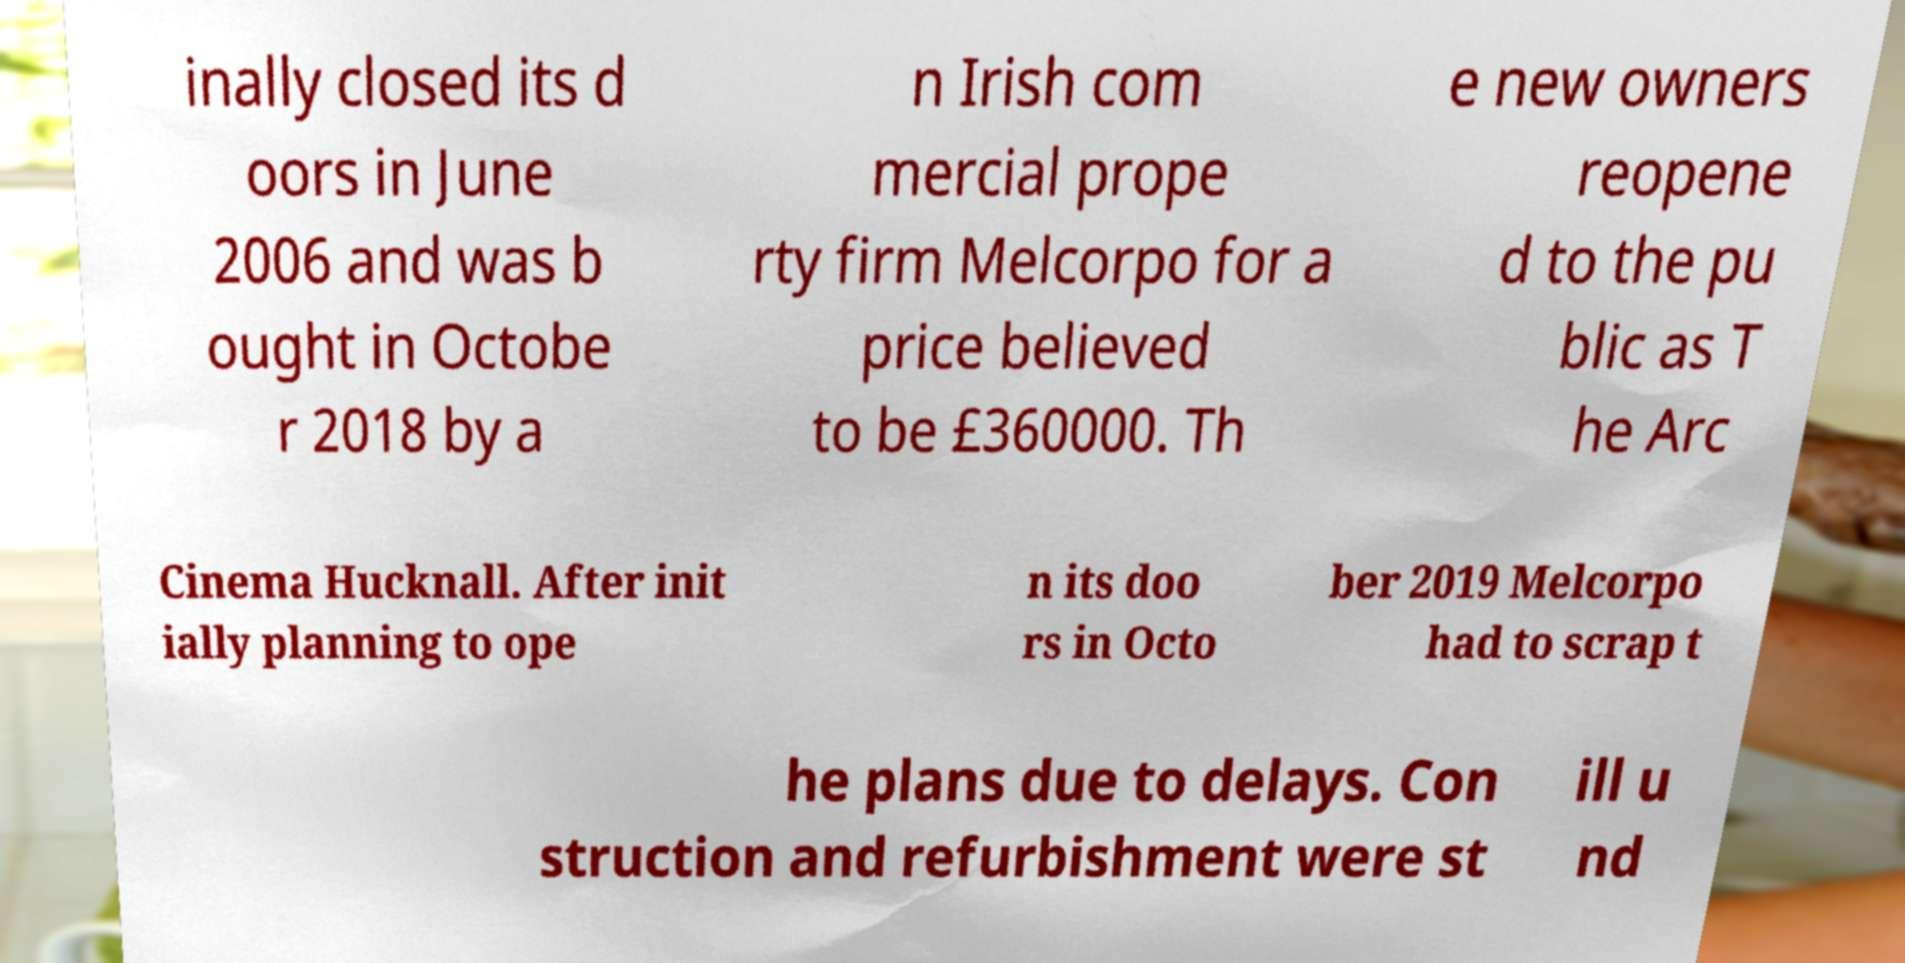For documentation purposes, I need the text within this image transcribed. Could you provide that? inally closed its d oors in June 2006 and was b ought in Octobe r 2018 by a n Irish com mercial prope rty firm Melcorpo for a price believed to be £360000. Th e new owners reopene d to the pu blic as T he Arc Cinema Hucknall. After init ially planning to ope n its doo rs in Octo ber 2019 Melcorpo had to scrap t he plans due to delays. Con struction and refurbishment were st ill u nd 